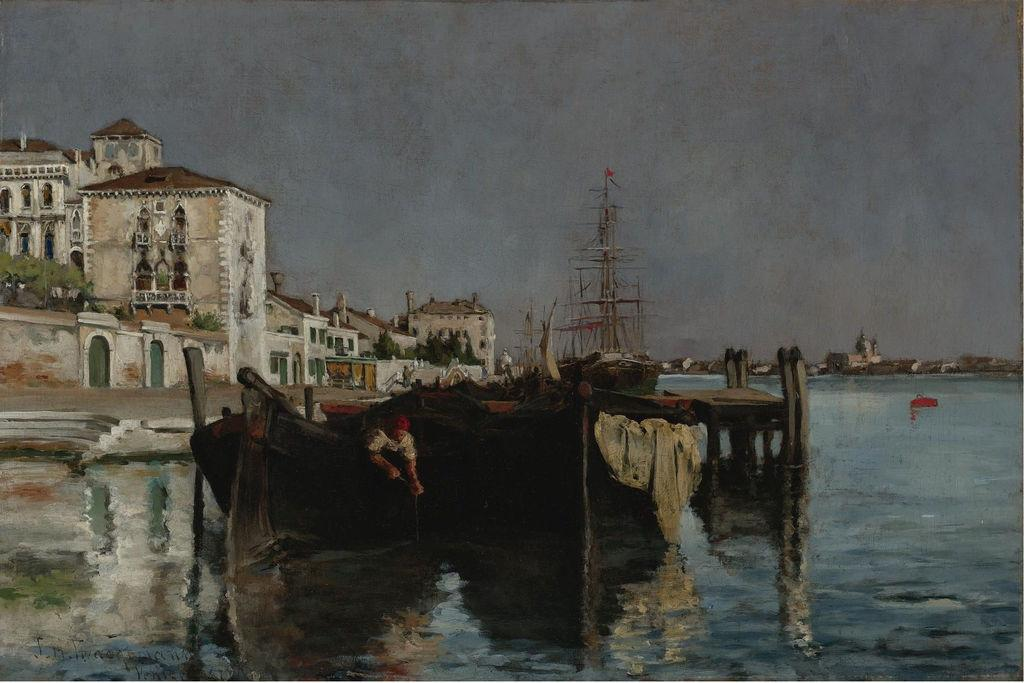What city is depicted in the image? The image depicts a view of Venice. What type of structures can be seen in the image? There are houses in the image. What type of vegetation is present in the image? There are trees in the image. What natural feature is visible in the image? There is water visible in the image. What is the smell of the water in the image? The image does not convey any information about the smell of the water, as it is a visual medium. 